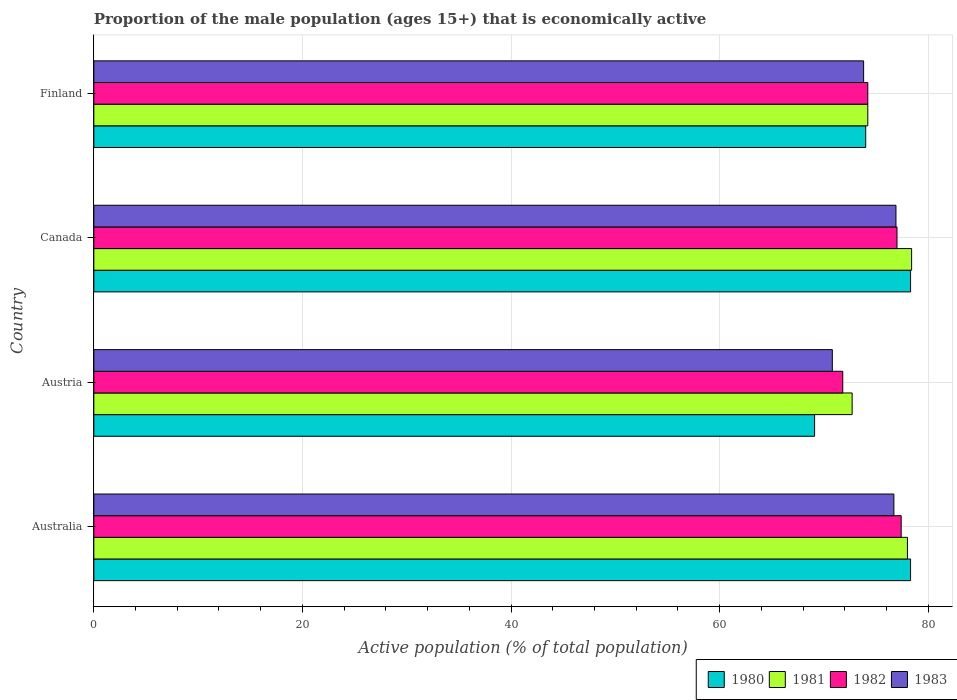Are the number of bars per tick equal to the number of legend labels?
Ensure brevity in your answer.  Yes. How many bars are there on the 1st tick from the bottom?
Your answer should be compact. 4. What is the label of the 2nd group of bars from the top?
Provide a short and direct response. Canada. In how many cases, is the number of bars for a given country not equal to the number of legend labels?
Provide a succinct answer. 0. What is the proportion of the male population that is economically active in 1983 in Australia?
Your answer should be very brief. 76.7. Across all countries, what is the maximum proportion of the male population that is economically active in 1983?
Your answer should be very brief. 76.9. Across all countries, what is the minimum proportion of the male population that is economically active in 1982?
Give a very brief answer. 71.8. In which country was the proportion of the male population that is economically active in 1982 maximum?
Your answer should be very brief. Australia. In which country was the proportion of the male population that is economically active in 1980 minimum?
Give a very brief answer. Austria. What is the total proportion of the male population that is economically active in 1980 in the graph?
Ensure brevity in your answer.  299.7. What is the difference between the proportion of the male population that is economically active in 1983 in Australia and that in Finland?
Your answer should be very brief. 2.9. What is the average proportion of the male population that is economically active in 1982 per country?
Make the answer very short. 75.1. What is the difference between the proportion of the male population that is economically active in 1983 and proportion of the male population that is economically active in 1980 in Finland?
Offer a terse response. -0.2. In how many countries, is the proportion of the male population that is economically active in 1983 greater than 48 %?
Your response must be concise. 4. What is the ratio of the proportion of the male population that is economically active in 1981 in Australia to that in Canada?
Keep it short and to the point. 0.99. Is the proportion of the male population that is economically active in 1982 in Australia less than that in Finland?
Provide a short and direct response. No. Is the difference between the proportion of the male population that is economically active in 1983 in Australia and Canada greater than the difference between the proportion of the male population that is economically active in 1980 in Australia and Canada?
Make the answer very short. No. What is the difference between the highest and the second highest proportion of the male population that is economically active in 1980?
Make the answer very short. 0. What is the difference between the highest and the lowest proportion of the male population that is economically active in 1983?
Offer a terse response. 6.1. In how many countries, is the proportion of the male population that is economically active in 1981 greater than the average proportion of the male population that is economically active in 1981 taken over all countries?
Give a very brief answer. 2. Is the sum of the proportion of the male population that is economically active in 1981 in Austria and Canada greater than the maximum proportion of the male population that is economically active in 1980 across all countries?
Provide a succinct answer. Yes. Is it the case that in every country, the sum of the proportion of the male population that is economically active in 1983 and proportion of the male population that is economically active in 1981 is greater than the sum of proportion of the male population that is economically active in 1980 and proportion of the male population that is economically active in 1982?
Your answer should be compact. No. What does the 1st bar from the top in Australia represents?
Your answer should be very brief. 1983. What does the 2nd bar from the bottom in Austria represents?
Your answer should be very brief. 1981. How many bars are there?
Your answer should be compact. 16. What is the difference between two consecutive major ticks on the X-axis?
Give a very brief answer. 20. Are the values on the major ticks of X-axis written in scientific E-notation?
Your answer should be compact. No. Where does the legend appear in the graph?
Provide a short and direct response. Bottom right. How are the legend labels stacked?
Keep it short and to the point. Horizontal. What is the title of the graph?
Your answer should be very brief. Proportion of the male population (ages 15+) that is economically active. What is the label or title of the X-axis?
Keep it short and to the point. Active population (% of total population). What is the Active population (% of total population) in 1980 in Australia?
Make the answer very short. 78.3. What is the Active population (% of total population) in 1982 in Australia?
Provide a succinct answer. 77.4. What is the Active population (% of total population) of 1983 in Australia?
Your answer should be very brief. 76.7. What is the Active population (% of total population) of 1980 in Austria?
Offer a very short reply. 69.1. What is the Active population (% of total population) in 1981 in Austria?
Make the answer very short. 72.7. What is the Active population (% of total population) of 1982 in Austria?
Offer a terse response. 71.8. What is the Active population (% of total population) in 1983 in Austria?
Keep it short and to the point. 70.8. What is the Active population (% of total population) of 1980 in Canada?
Your response must be concise. 78.3. What is the Active population (% of total population) in 1981 in Canada?
Make the answer very short. 78.4. What is the Active population (% of total population) in 1983 in Canada?
Ensure brevity in your answer.  76.9. What is the Active population (% of total population) in 1981 in Finland?
Make the answer very short. 74.2. What is the Active population (% of total population) of 1982 in Finland?
Ensure brevity in your answer.  74.2. What is the Active population (% of total population) of 1983 in Finland?
Provide a succinct answer. 73.8. Across all countries, what is the maximum Active population (% of total population) of 1980?
Give a very brief answer. 78.3. Across all countries, what is the maximum Active population (% of total population) in 1981?
Keep it short and to the point. 78.4. Across all countries, what is the maximum Active population (% of total population) in 1982?
Give a very brief answer. 77.4. Across all countries, what is the maximum Active population (% of total population) in 1983?
Make the answer very short. 76.9. Across all countries, what is the minimum Active population (% of total population) of 1980?
Provide a short and direct response. 69.1. Across all countries, what is the minimum Active population (% of total population) of 1981?
Offer a very short reply. 72.7. Across all countries, what is the minimum Active population (% of total population) in 1982?
Give a very brief answer. 71.8. Across all countries, what is the minimum Active population (% of total population) of 1983?
Your answer should be very brief. 70.8. What is the total Active population (% of total population) in 1980 in the graph?
Your answer should be very brief. 299.7. What is the total Active population (% of total population) of 1981 in the graph?
Keep it short and to the point. 303.3. What is the total Active population (% of total population) of 1982 in the graph?
Offer a very short reply. 300.4. What is the total Active population (% of total population) of 1983 in the graph?
Offer a very short reply. 298.2. What is the difference between the Active population (% of total population) in 1982 in Australia and that in Austria?
Your response must be concise. 5.6. What is the difference between the Active population (% of total population) of 1980 in Australia and that in Canada?
Make the answer very short. 0. What is the difference between the Active population (% of total population) of 1982 in Australia and that in Canada?
Give a very brief answer. 0.4. What is the difference between the Active population (% of total population) of 1983 in Australia and that in Canada?
Ensure brevity in your answer.  -0.2. What is the difference between the Active population (% of total population) in 1981 in Australia and that in Finland?
Your answer should be very brief. 3.8. What is the difference between the Active population (% of total population) of 1982 in Australia and that in Finland?
Provide a succinct answer. 3.2. What is the difference between the Active population (% of total population) in 1980 in Austria and that in Canada?
Offer a terse response. -9.2. What is the difference between the Active population (% of total population) in 1981 in Austria and that in Canada?
Offer a terse response. -5.7. What is the difference between the Active population (% of total population) in 1982 in Austria and that in Canada?
Offer a terse response. -5.2. What is the difference between the Active population (% of total population) in 1983 in Austria and that in Canada?
Provide a succinct answer. -6.1. What is the difference between the Active population (% of total population) in 1981 in Austria and that in Finland?
Offer a very short reply. -1.5. What is the difference between the Active population (% of total population) in 1980 in Canada and that in Finland?
Offer a terse response. 4.3. What is the difference between the Active population (% of total population) of 1981 in Canada and that in Finland?
Make the answer very short. 4.2. What is the difference between the Active population (% of total population) in 1982 in Canada and that in Finland?
Your response must be concise. 2.8. What is the difference between the Active population (% of total population) in 1981 in Australia and the Active population (% of total population) in 1982 in Austria?
Make the answer very short. 6.2. What is the difference between the Active population (% of total population) of 1981 in Australia and the Active population (% of total population) of 1983 in Austria?
Give a very brief answer. 7.2. What is the difference between the Active population (% of total population) in 1982 in Australia and the Active population (% of total population) in 1983 in Austria?
Your answer should be very brief. 6.6. What is the difference between the Active population (% of total population) of 1980 in Australia and the Active population (% of total population) of 1981 in Canada?
Ensure brevity in your answer.  -0.1. What is the difference between the Active population (% of total population) of 1980 in Australia and the Active population (% of total population) of 1983 in Canada?
Offer a terse response. 1.4. What is the difference between the Active population (% of total population) in 1981 in Australia and the Active population (% of total population) in 1982 in Canada?
Provide a succinct answer. 1. What is the difference between the Active population (% of total population) of 1981 in Australia and the Active population (% of total population) of 1983 in Canada?
Offer a terse response. 1.1. What is the difference between the Active population (% of total population) of 1981 in Australia and the Active population (% of total population) of 1982 in Finland?
Ensure brevity in your answer.  3.8. What is the difference between the Active population (% of total population) of 1981 in Austria and the Active population (% of total population) of 1983 in Canada?
Make the answer very short. -4.2. What is the difference between the Active population (% of total population) in 1982 in Austria and the Active population (% of total population) in 1983 in Canada?
Make the answer very short. -5.1. What is the difference between the Active population (% of total population) in 1980 in Austria and the Active population (% of total population) in 1981 in Finland?
Offer a very short reply. -5.1. What is the difference between the Active population (% of total population) in 1980 in Canada and the Active population (% of total population) in 1983 in Finland?
Keep it short and to the point. 4.5. What is the difference between the Active population (% of total population) in 1981 in Canada and the Active population (% of total population) in 1982 in Finland?
Ensure brevity in your answer.  4.2. What is the average Active population (% of total population) of 1980 per country?
Your answer should be very brief. 74.92. What is the average Active population (% of total population) in 1981 per country?
Offer a very short reply. 75.83. What is the average Active population (% of total population) in 1982 per country?
Offer a terse response. 75.1. What is the average Active population (% of total population) of 1983 per country?
Provide a succinct answer. 74.55. What is the difference between the Active population (% of total population) of 1980 and Active population (% of total population) of 1981 in Australia?
Keep it short and to the point. 0.3. What is the difference between the Active population (% of total population) of 1980 and Active population (% of total population) of 1982 in Australia?
Ensure brevity in your answer.  0.9. What is the difference between the Active population (% of total population) of 1981 and Active population (% of total population) of 1982 in Australia?
Provide a short and direct response. 0.6. What is the difference between the Active population (% of total population) of 1981 and Active population (% of total population) of 1983 in Australia?
Give a very brief answer. 1.3. What is the difference between the Active population (% of total population) of 1980 and Active population (% of total population) of 1981 in Austria?
Provide a short and direct response. -3.6. What is the difference between the Active population (% of total population) of 1980 and Active population (% of total population) of 1983 in Austria?
Your response must be concise. -1.7. What is the difference between the Active population (% of total population) in 1981 and Active population (% of total population) in 1983 in Austria?
Offer a terse response. 1.9. What is the difference between the Active population (% of total population) of 1980 and Active population (% of total population) of 1981 in Canada?
Provide a short and direct response. -0.1. What is the difference between the Active population (% of total population) in 1980 and Active population (% of total population) in 1982 in Canada?
Provide a short and direct response. 1.3. What is the difference between the Active population (% of total population) in 1980 and Active population (% of total population) in 1983 in Canada?
Your answer should be compact. 1.4. What is the difference between the Active population (% of total population) of 1981 and Active population (% of total population) of 1982 in Canada?
Make the answer very short. 1.4. What is the difference between the Active population (% of total population) in 1982 and Active population (% of total population) in 1983 in Canada?
Keep it short and to the point. 0.1. What is the difference between the Active population (% of total population) of 1980 and Active population (% of total population) of 1983 in Finland?
Your response must be concise. 0.2. What is the difference between the Active population (% of total population) in 1981 and Active population (% of total population) in 1983 in Finland?
Keep it short and to the point. 0.4. What is the ratio of the Active population (% of total population) of 1980 in Australia to that in Austria?
Offer a terse response. 1.13. What is the ratio of the Active population (% of total population) of 1981 in Australia to that in Austria?
Your answer should be very brief. 1.07. What is the ratio of the Active population (% of total population) in 1982 in Australia to that in Austria?
Keep it short and to the point. 1.08. What is the ratio of the Active population (% of total population) of 1983 in Australia to that in Austria?
Your answer should be very brief. 1.08. What is the ratio of the Active population (% of total population) of 1981 in Australia to that in Canada?
Ensure brevity in your answer.  0.99. What is the ratio of the Active population (% of total population) of 1982 in Australia to that in Canada?
Ensure brevity in your answer.  1.01. What is the ratio of the Active population (% of total population) in 1980 in Australia to that in Finland?
Your answer should be compact. 1.06. What is the ratio of the Active population (% of total population) in 1981 in Australia to that in Finland?
Your answer should be compact. 1.05. What is the ratio of the Active population (% of total population) in 1982 in Australia to that in Finland?
Ensure brevity in your answer.  1.04. What is the ratio of the Active population (% of total population) in 1983 in Australia to that in Finland?
Give a very brief answer. 1.04. What is the ratio of the Active population (% of total population) in 1980 in Austria to that in Canada?
Offer a terse response. 0.88. What is the ratio of the Active population (% of total population) in 1981 in Austria to that in Canada?
Your answer should be very brief. 0.93. What is the ratio of the Active population (% of total population) in 1982 in Austria to that in Canada?
Offer a terse response. 0.93. What is the ratio of the Active population (% of total population) of 1983 in Austria to that in Canada?
Provide a short and direct response. 0.92. What is the ratio of the Active population (% of total population) in 1980 in Austria to that in Finland?
Provide a short and direct response. 0.93. What is the ratio of the Active population (% of total population) in 1981 in Austria to that in Finland?
Provide a short and direct response. 0.98. What is the ratio of the Active population (% of total population) in 1982 in Austria to that in Finland?
Your answer should be very brief. 0.97. What is the ratio of the Active population (% of total population) in 1983 in Austria to that in Finland?
Keep it short and to the point. 0.96. What is the ratio of the Active population (% of total population) in 1980 in Canada to that in Finland?
Make the answer very short. 1.06. What is the ratio of the Active population (% of total population) in 1981 in Canada to that in Finland?
Keep it short and to the point. 1.06. What is the ratio of the Active population (% of total population) in 1982 in Canada to that in Finland?
Your response must be concise. 1.04. What is the ratio of the Active population (% of total population) in 1983 in Canada to that in Finland?
Keep it short and to the point. 1.04. What is the difference between the highest and the second highest Active population (% of total population) in 1980?
Give a very brief answer. 0. What is the difference between the highest and the second highest Active population (% of total population) of 1982?
Offer a terse response. 0.4. What is the difference between the highest and the lowest Active population (% of total population) in 1983?
Keep it short and to the point. 6.1. 